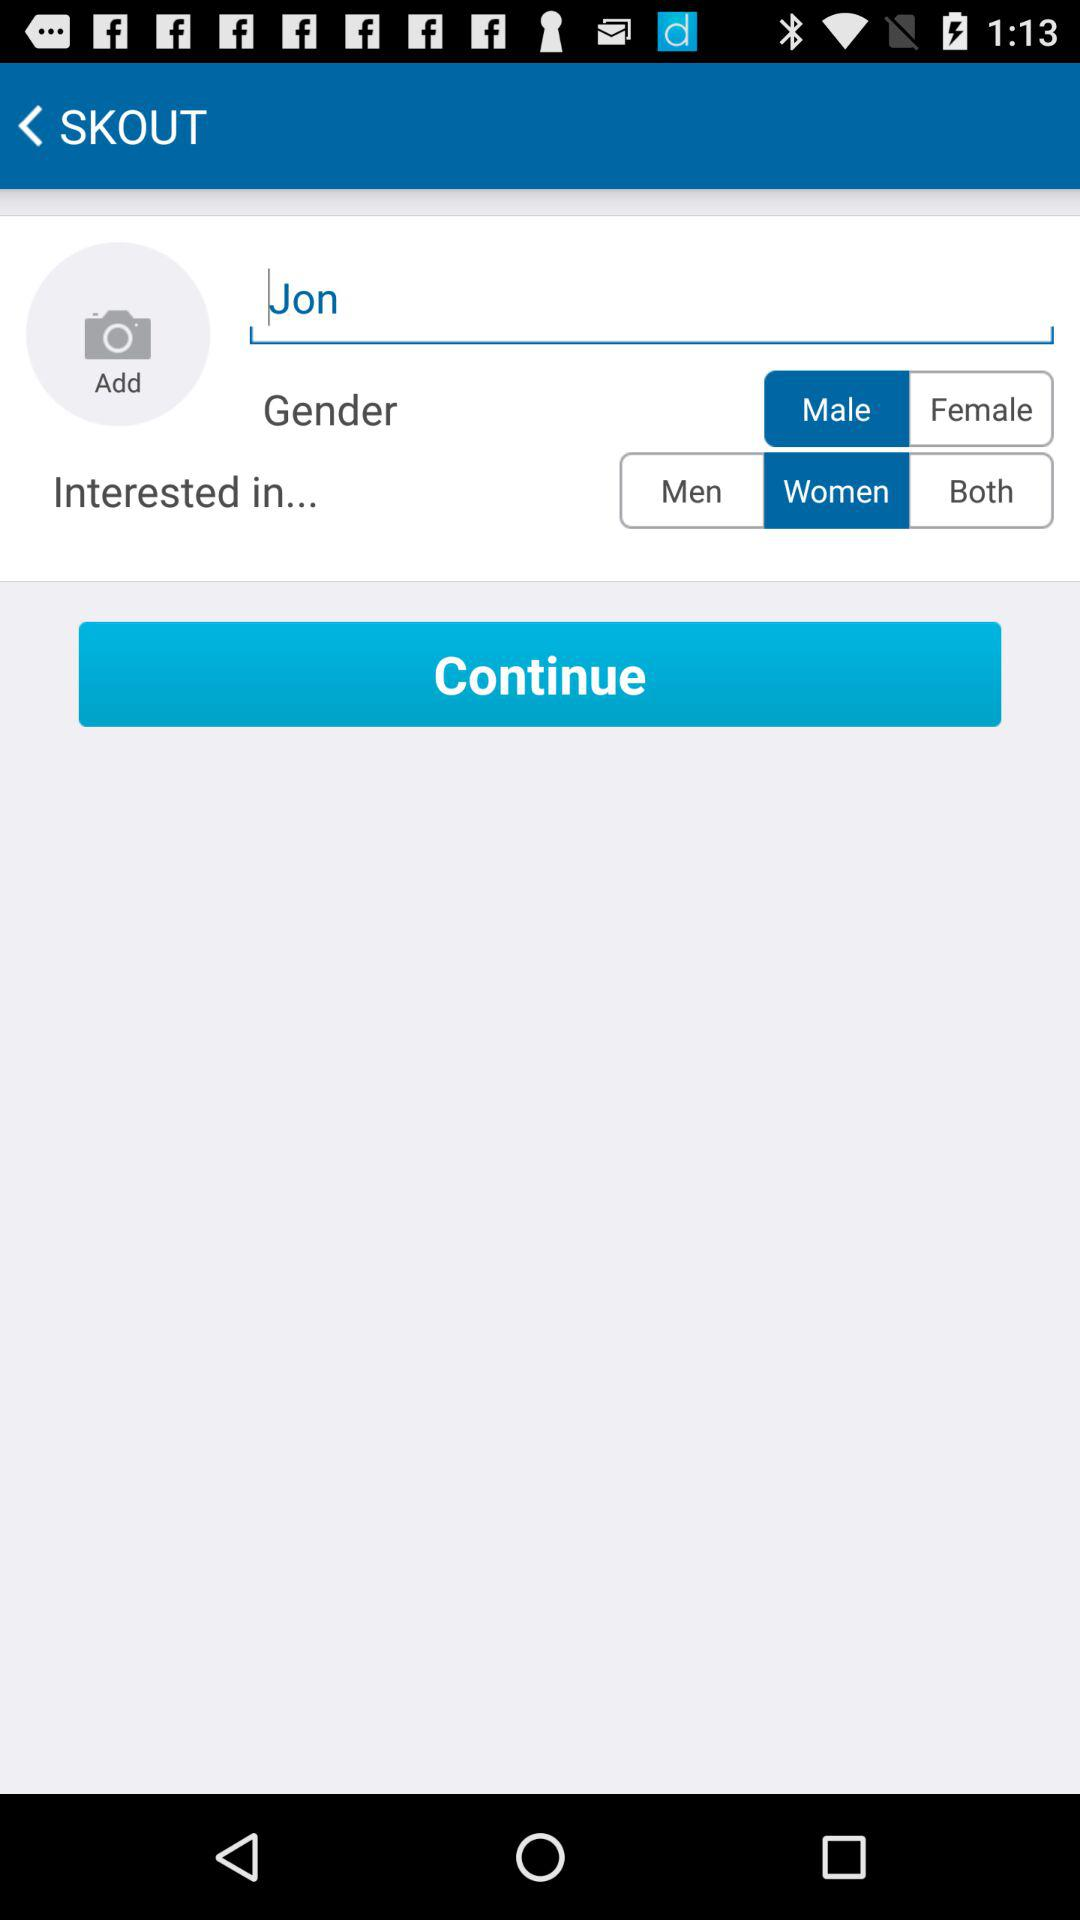What are Jon's interests? Jon is interested in women. 